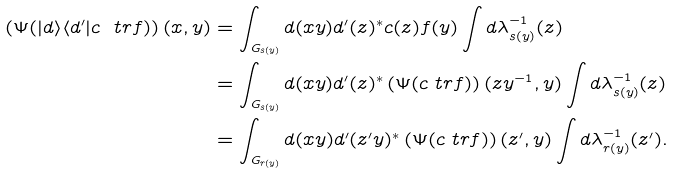<formula> <loc_0><loc_0><loc_500><loc_500>\left ( \Psi ( | d \rangle \langle d ^ { \prime } | c \ t r f ) \right ) ( x , y ) & = \int _ { G _ { s ( y ) } } d ( x y ) d ^ { \prime } ( z ) ^ { * } c ( z ) f ( y ) \int d \lambda ^ { - 1 } _ { s ( y ) } ( z ) \\ & = \int _ { G _ { s ( y ) } } d ( x y ) d ^ { \prime } ( z ) ^ { * } \left ( \Psi ( c \ t r f ) \right ) ( z y ^ { - 1 } , y ) \int d \lambda ^ { - 1 } _ { s ( y ) } ( z ) \\ & = \int _ { G _ { r ( y ) } } d ( x y ) d ^ { \prime } ( z ^ { \prime } y ) ^ { * } \left ( \Psi ( c \ t r f ) \right ) ( z ^ { \prime } , y ) \int d \lambda ^ { - 1 } _ { r ( y ) } ( z ^ { \prime } ) .</formula> 